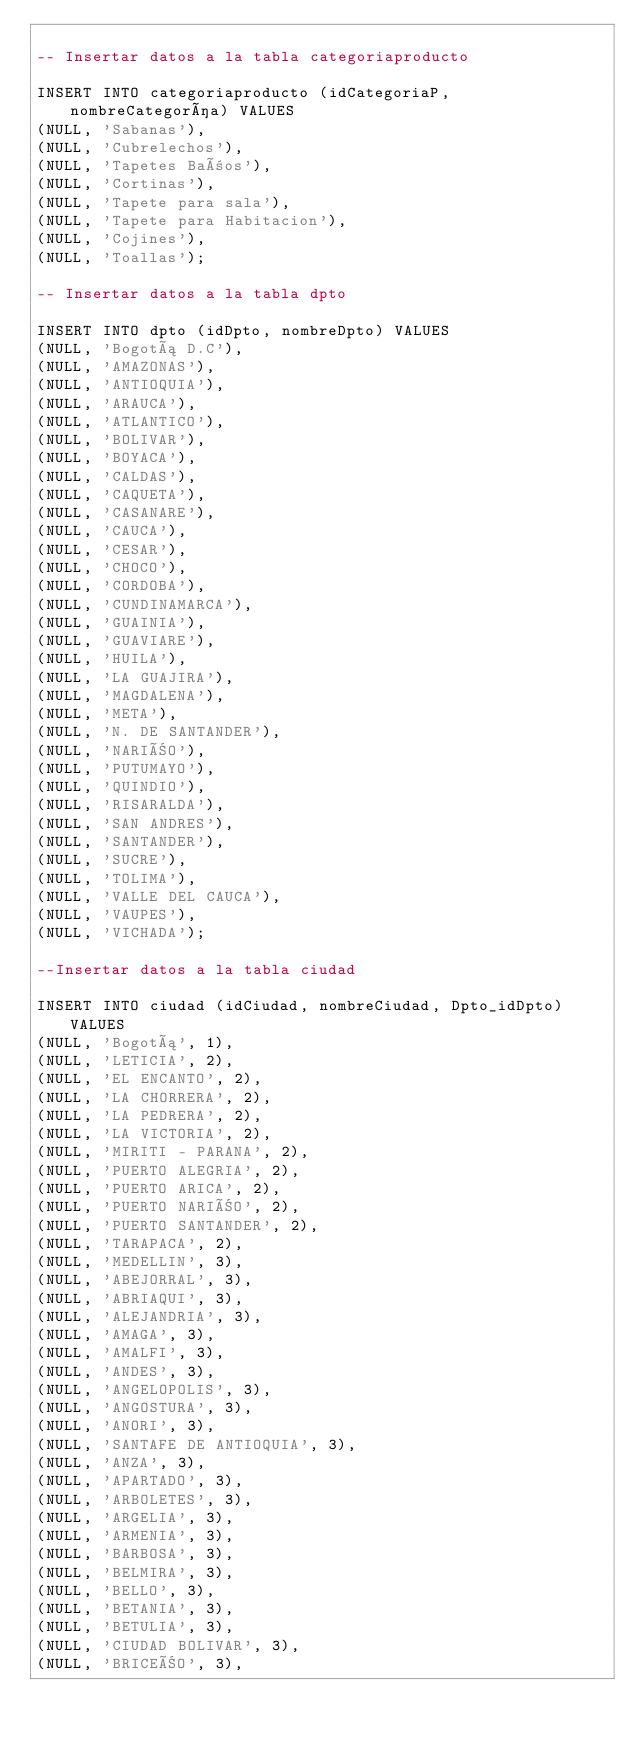Convert code to text. <code><loc_0><loc_0><loc_500><loc_500><_SQL_>
-- Insertar datos a la tabla categoriaproducto

INSERT INTO categoriaproducto (idCategoriaP, nombreCategoría) VALUES
(NULL, 'Sabanas'),
(NULL, 'Cubrelechos'),
(NULL, 'Tapetes Baños'),
(NULL, 'Cortinas'),
(NULL, 'Tapete para sala'),
(NULL, 'Tapete para Habitacion'),
(NULL, 'Cojines'),
(NULL, 'Toallas');

-- Insertar datos a la tabla dpto

INSERT INTO dpto (idDpto, nombreDpto) VALUES
(NULL, 'Bogotá D.C'),
(NULL, 'AMAZONAS'),
(NULL, 'ANTIOQUIA'),
(NULL, 'ARAUCA'),
(NULL, 'ATLANTICO'),
(NULL, 'BOLIVAR'),
(NULL, 'BOYACA'),
(NULL, 'CALDAS'),
(NULL, 'CAQUETA'),
(NULL, 'CASANARE'),
(NULL, 'CAUCA'),
(NULL, 'CESAR'),
(NULL, 'CHOCO'),
(NULL, 'CORDOBA'),
(NULL, 'CUNDINAMARCA'),
(NULL, 'GUAINIA'),
(NULL, 'GUAVIARE'),
(NULL, 'HUILA'),
(NULL, 'LA GUAJIRA'),
(NULL, 'MAGDALENA'),
(NULL, 'META'),
(NULL, 'N. DE SANTANDER'),
(NULL, 'NARIÑO'),
(NULL, 'PUTUMAYO'),
(NULL, 'QUINDIO'),
(NULL, 'RISARALDA'),
(NULL, 'SAN ANDRES'),
(NULL, 'SANTANDER'),
(NULL, 'SUCRE'),
(NULL, 'TOLIMA'),
(NULL, 'VALLE DEL CAUCA'),
(NULL, 'VAUPES'),
(NULL, 'VICHADA');

--Insertar datos a la tabla ciudad

INSERT INTO ciudad (idCiudad, nombreCiudad, Dpto_idDpto) VALUES
(NULL, 'Bogotá', 1),
(NULL, 'LETICIA', 2),
(NULL, 'EL ENCANTO', 2),
(NULL, 'LA CHORRERA', 2),
(NULL, 'LA PEDRERA', 2),
(NULL, 'LA VICTORIA', 2),
(NULL, 'MIRITI - PARANA', 2),
(NULL, 'PUERTO ALEGRIA', 2),
(NULL, 'PUERTO ARICA', 2),
(NULL, 'PUERTO NARIÑO', 2),
(NULL, 'PUERTO SANTANDER', 2),
(NULL, 'TARAPACA', 2),
(NULL, 'MEDELLIN', 3),
(NULL, 'ABEJORRAL', 3),
(NULL, 'ABRIAQUI', 3),
(NULL, 'ALEJANDRIA', 3),
(NULL, 'AMAGA', 3),
(NULL, 'AMALFI', 3),
(NULL, 'ANDES', 3),
(NULL, 'ANGELOPOLIS', 3),
(NULL, 'ANGOSTURA', 3),
(NULL, 'ANORI', 3),
(NULL, 'SANTAFE DE ANTIOQUIA', 3),
(NULL, 'ANZA', 3),
(NULL, 'APARTADO', 3),
(NULL, 'ARBOLETES', 3),
(NULL, 'ARGELIA', 3),
(NULL, 'ARMENIA', 3),
(NULL, 'BARBOSA', 3),
(NULL, 'BELMIRA', 3),
(NULL, 'BELLO', 3),
(NULL, 'BETANIA', 3),
(NULL, 'BETULIA', 3),
(NULL, 'CIUDAD BOLIVAR', 3),
(NULL, 'BRICEÑO', 3),</code> 